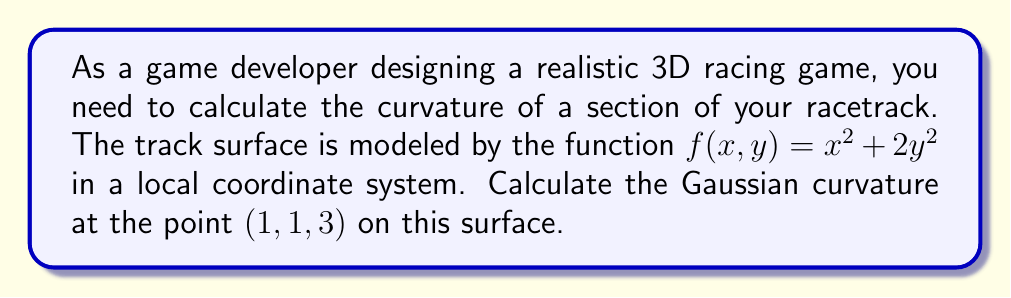Give your solution to this math problem. To calculate the Gaussian curvature of the surface at the given point, we'll follow these steps:

1) The Gaussian curvature K is given by:

   $$K = \frac{LN - M^2}{EG - F^2}$$

   where L, M, N are coefficients of the second fundamental form, and E, F, G are coefficients of the first fundamental form.

2) First, let's calculate the partial derivatives:

   $$f_x = 2x, \quad f_y = 4y, \quad f_{xx} = 2, \quad f_{yy} = 4, \quad f_{xy} = 0$$

3) Now, we can calculate E, F, and G:

   $$E = 1 + f_x^2 = 1 + 4x^2$$
   $$F = f_x f_y = 8xy$$
   $$G = 1 + f_y^2 = 1 + 16y^2$$

4) Next, we calculate the unit normal vector:

   $$\vec{n} = \frac{(-f_x, -f_y, 1)}{\sqrt{1 + f_x^2 + f_y^2}} = \frac{(-2x, -4y, 1)}{\sqrt{1 + 4x^2 + 16y^2}}$$

5) Now we can calculate L, M, and N:

   $$L = \frac{f_{xx}}{\sqrt{1 + f_x^2 + f_y^2}} = \frac{2}{\sqrt{1 + 4x^2 + 16y^2}}$$
   $$M = \frac{f_{xy}}{\sqrt{1 + f_x^2 + f_y^2}} = 0$$
   $$N = \frac{f_{yy}}{\sqrt{1 + f_x^2 + f_y^2}} = \frac{4}{\sqrt{1 + 4x^2 + 16y^2}}$$

6) Now we can substitute these values into the Gaussian curvature formula:

   $$K = \frac{LN - M^2}{EG - F^2} = \frac{\frac{8}{1 + 4x^2 + 16y^2} - 0}{(1 + 4x^2)(1 + 16y^2) - 64x^2y^2}$$

7) At the point (1, 1, 3), we have x = 1 and y = 1. Substituting these values:

   $$K = \frac{\frac{8}{1 + 4 + 16} - 0}{(1 + 4)(1 + 16) - 64} = \frac{8/21}{85 - 64} = \frac{8/21}{21} = \frac{8}{441}$$

Therefore, the Gaussian curvature at the point (1, 1, 3) is 8/441.
Answer: $\frac{8}{441}$ 